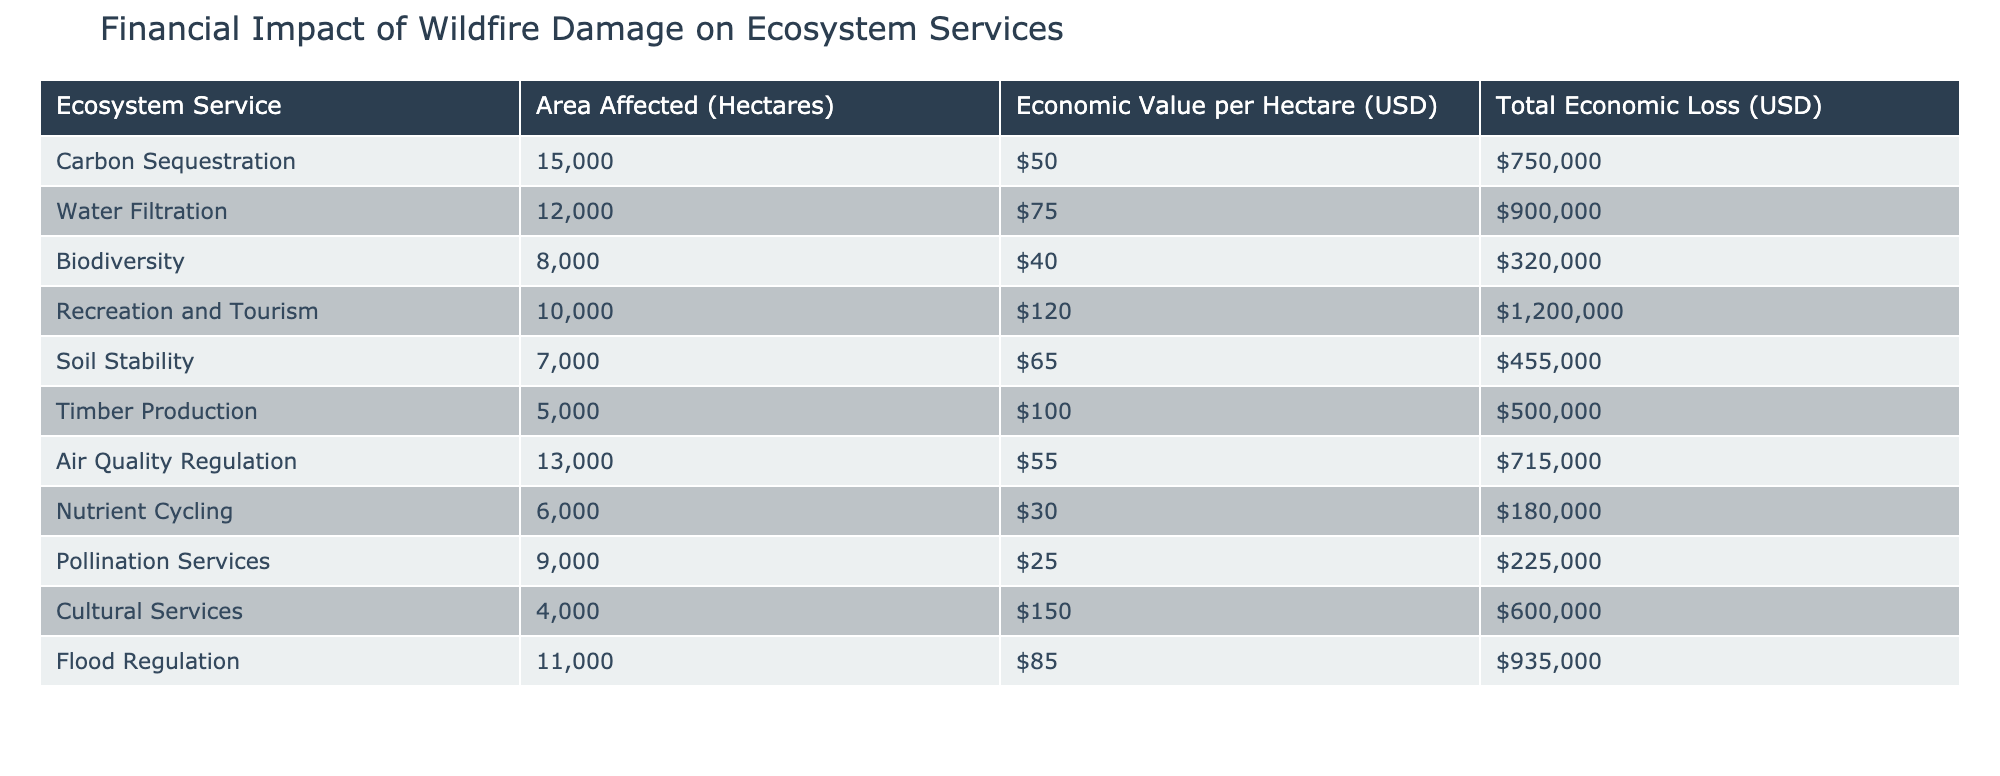What is the total economic loss from soil stability services? From the table, the total economic loss for soil stability is listed as $455,000.
Answer: $455,000 How many hectares were affected by water filtration services? The table indicates that 12,000 hectares were affected by water filtration.
Answer: 12,000 hectares What is the combined total economic loss for carbon sequestration and air quality regulation? The total economic loss for carbon sequestration is $750,000, and for air quality regulation it is $715,000. Adding these gives $750,000 + $715,000 = $1,465,000.
Answer: $1,465,000 Is the economic value per hectare for biodiversity higher than that for pollination services? The economic value per hectare for biodiversity is $40, while for pollination services it is $25. Since $40 is greater than $25, this is true.
Answer: Yes What is the average economic loss per hectare for the services listed in the table? To find this, add all total economic losses: $750,000 + $900,000 + $320,000 + $1,200,000 + $455,000 + $500,000 + $715,000 + $180,000 + $225,000 + $600,000 + $935,000 = $5,730,000. The total area affected is 15,000 + 12,000 + 8,000 + 10,000 + 7,000 + 5,000 + 13,000 + 6,000 + 9,000 + 4,000 + 11,000 =  96,000 hectares. Finally, dividing total losses by total area: $5,730,000 / 96,000 = $59.6875.
Answer: $59.69 How much economic loss is associated with recreation and tourism services? The recreation and tourism services incurred an economic loss of $1,200,000 as stated in the table.
Answer: $1,200,000 Is the total economic loss for flood regulation services greater than the combined losses for carbon sequestration and biodiversity? The total loss for flood regulation is $935,000, and the sum of carbon sequestration ($750,000) and biodiversity ($320,000) is $1,070,000. Since $935,000 is less than $1,070,000, this is false.
Answer: No What is the total area affected by all services listed in the table? To calculate this, we sum the affected areas for all services: 15,000 + 12,000 + 8,000 + 10,000 + 7,000 + 5,000 + 13,000 + 6,000 + 9,000 + 4,000 + 11,000 = 96,000 hectares.
Answer: 96,000 hectares Which service has the highest economic value per hectare? The table shows that cultural services have the highest economic value per hectare at $150.
Answer: Cultural services 